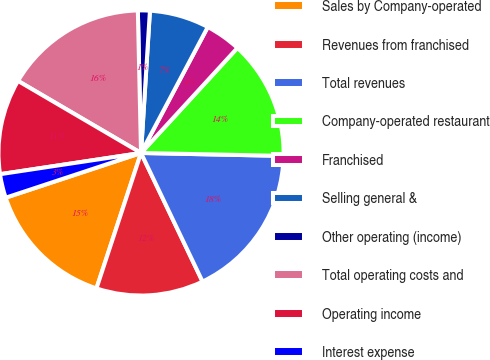Convert chart to OTSL. <chart><loc_0><loc_0><loc_500><loc_500><pie_chart><fcel>Sales by Company-operated<fcel>Revenues from franchised<fcel>Total revenues<fcel>Company-operated restaurant<fcel>Franchised<fcel>Selling general &<fcel>Other operating (income)<fcel>Total operating costs and<fcel>Operating income<fcel>Interest expense<nl><fcel>14.86%<fcel>12.16%<fcel>17.57%<fcel>13.51%<fcel>4.06%<fcel>6.76%<fcel>1.35%<fcel>16.21%<fcel>10.81%<fcel>2.7%<nl></chart> 